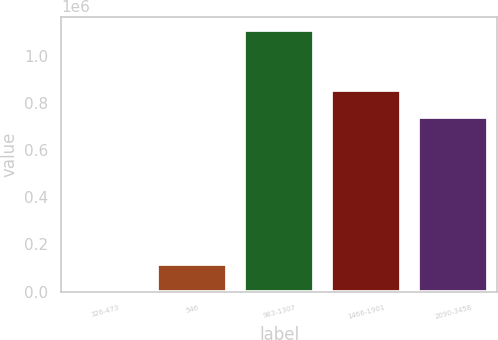<chart> <loc_0><loc_0><loc_500><loc_500><bar_chart><fcel>326-473<fcel>546<fcel>983-1307<fcel>1466-1901<fcel>2090-3458<nl><fcel>5244<fcel>115792<fcel>1.11072e+06<fcel>853097<fcel>741245<nl></chart> 